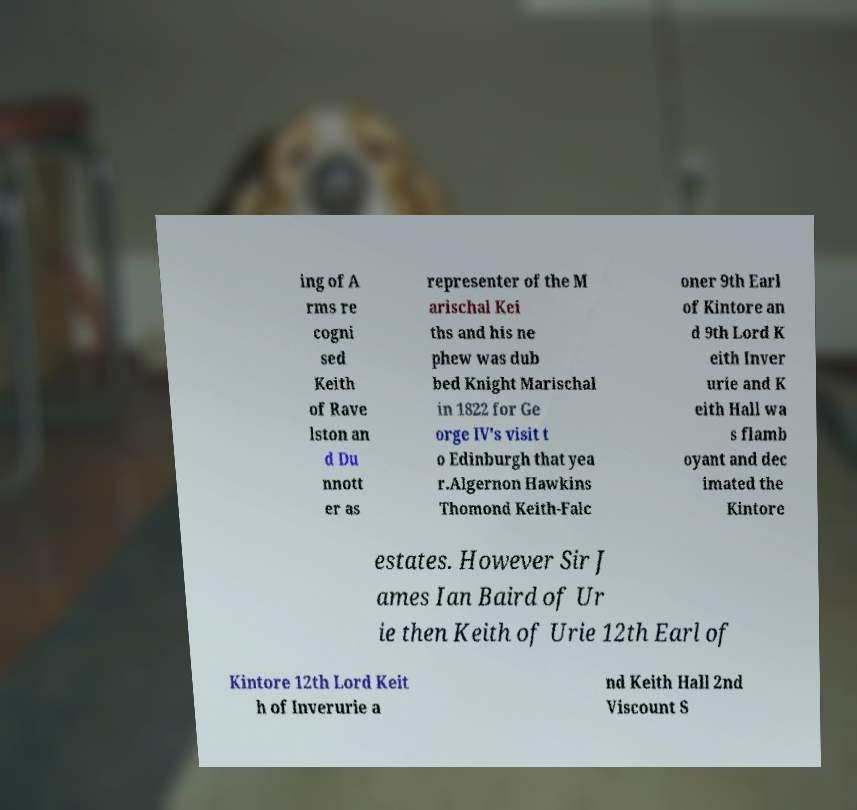Please read and relay the text visible in this image. What does it say? ing of A rms re cogni sed Keith of Rave lston an d Du nnott er as representer of the M arischal Kei ths and his ne phew was dub bed Knight Marischal in 1822 for Ge orge IV's visit t o Edinburgh that yea r.Algernon Hawkins Thomond Keith-Falc oner 9th Earl of Kintore an d 9th Lord K eith Inver urie and K eith Hall wa s flamb oyant and dec imated the Kintore estates. However Sir J ames Ian Baird of Ur ie then Keith of Urie 12th Earl of Kintore 12th Lord Keit h of Inverurie a nd Keith Hall 2nd Viscount S 